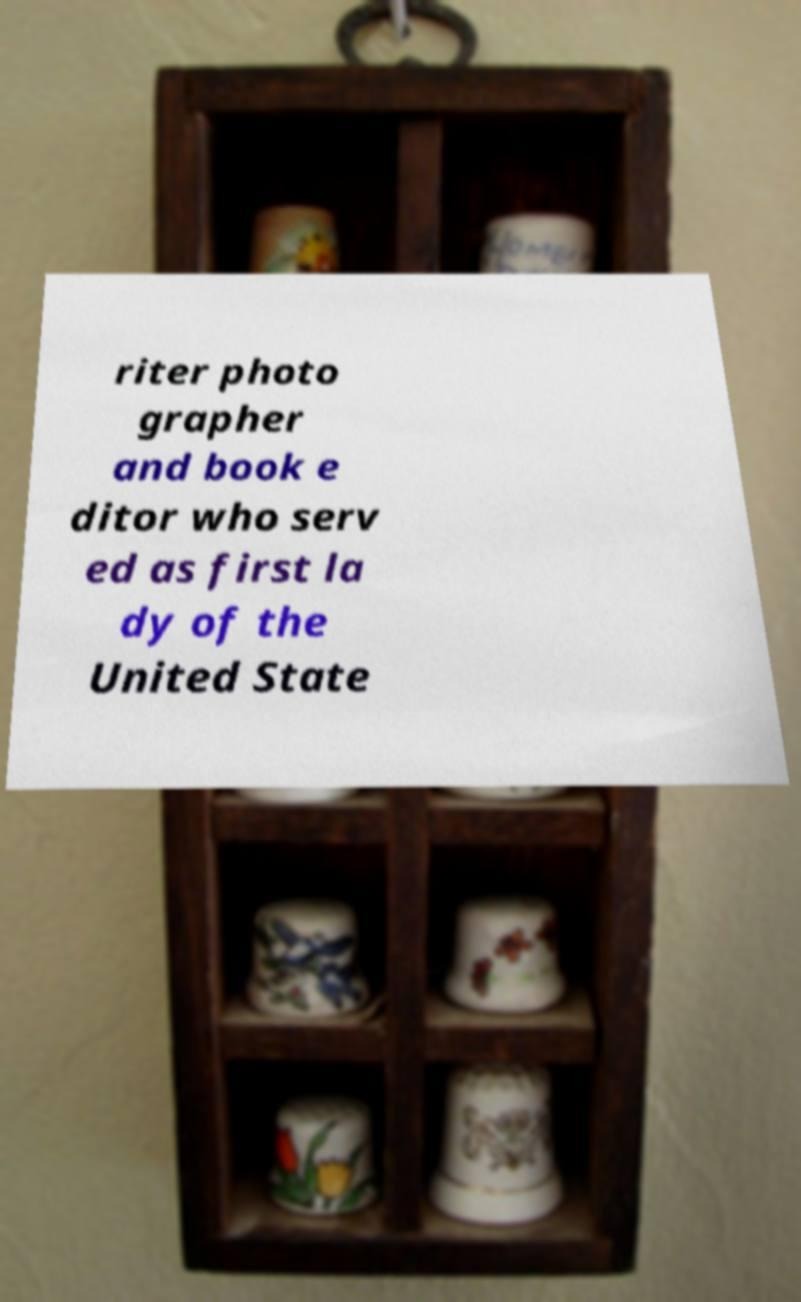There's text embedded in this image that I need extracted. Can you transcribe it verbatim? riter photo grapher and book e ditor who serv ed as first la dy of the United State 